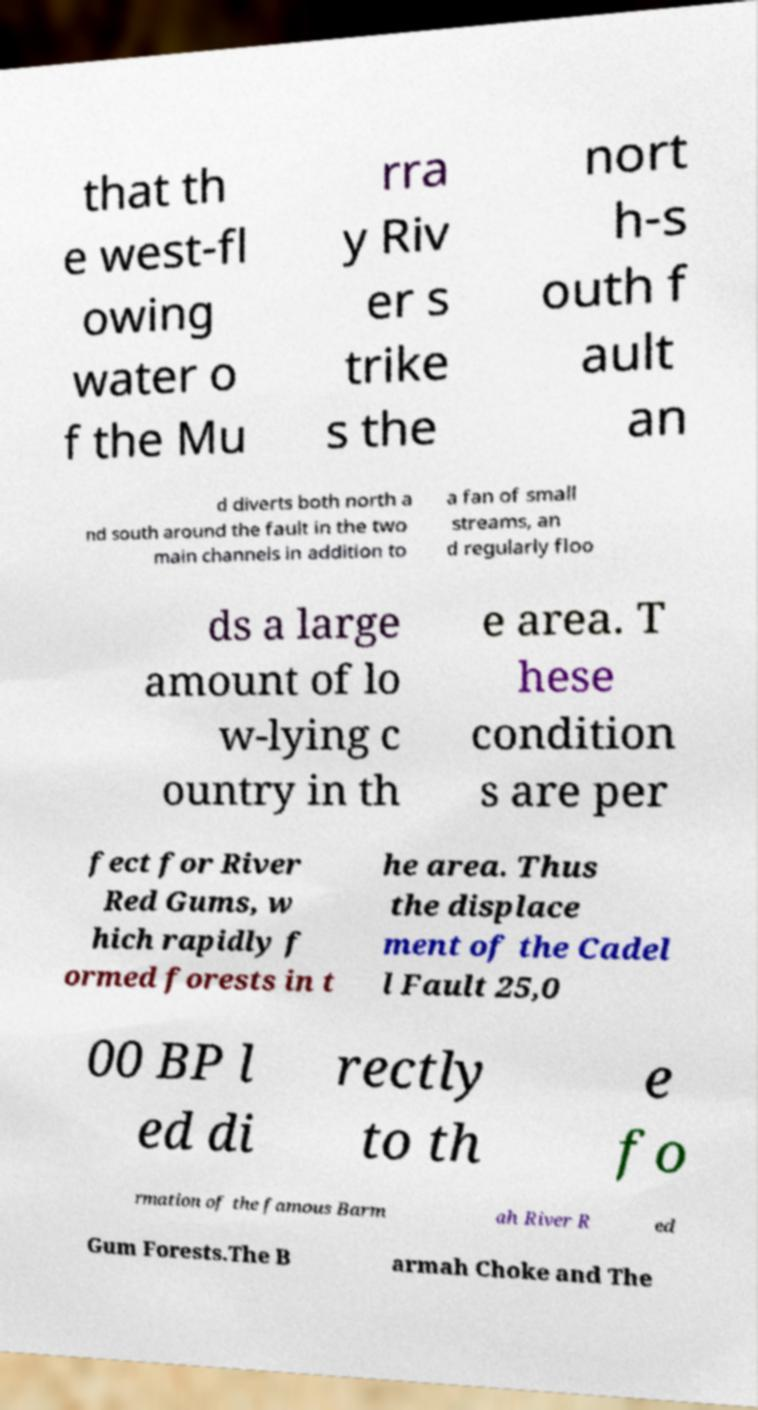Can you read and provide the text displayed in the image?This photo seems to have some interesting text. Can you extract and type it out for me? that th e west-fl owing water o f the Mu rra y Riv er s trike s the nort h-s outh f ault an d diverts both north a nd south around the fault in the two main channels in addition to a fan of small streams, an d regularly floo ds a large amount of lo w-lying c ountry in th e area. T hese condition s are per fect for River Red Gums, w hich rapidly f ormed forests in t he area. Thus the displace ment of the Cadel l Fault 25,0 00 BP l ed di rectly to th e fo rmation of the famous Barm ah River R ed Gum Forests.The B armah Choke and The 